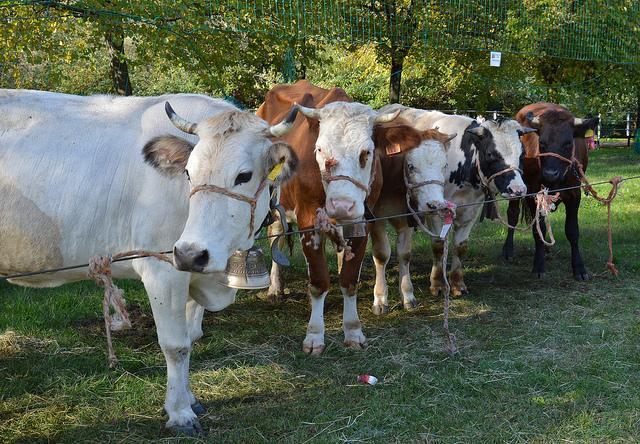How many cows are there?
Give a very brief answer. 5. 